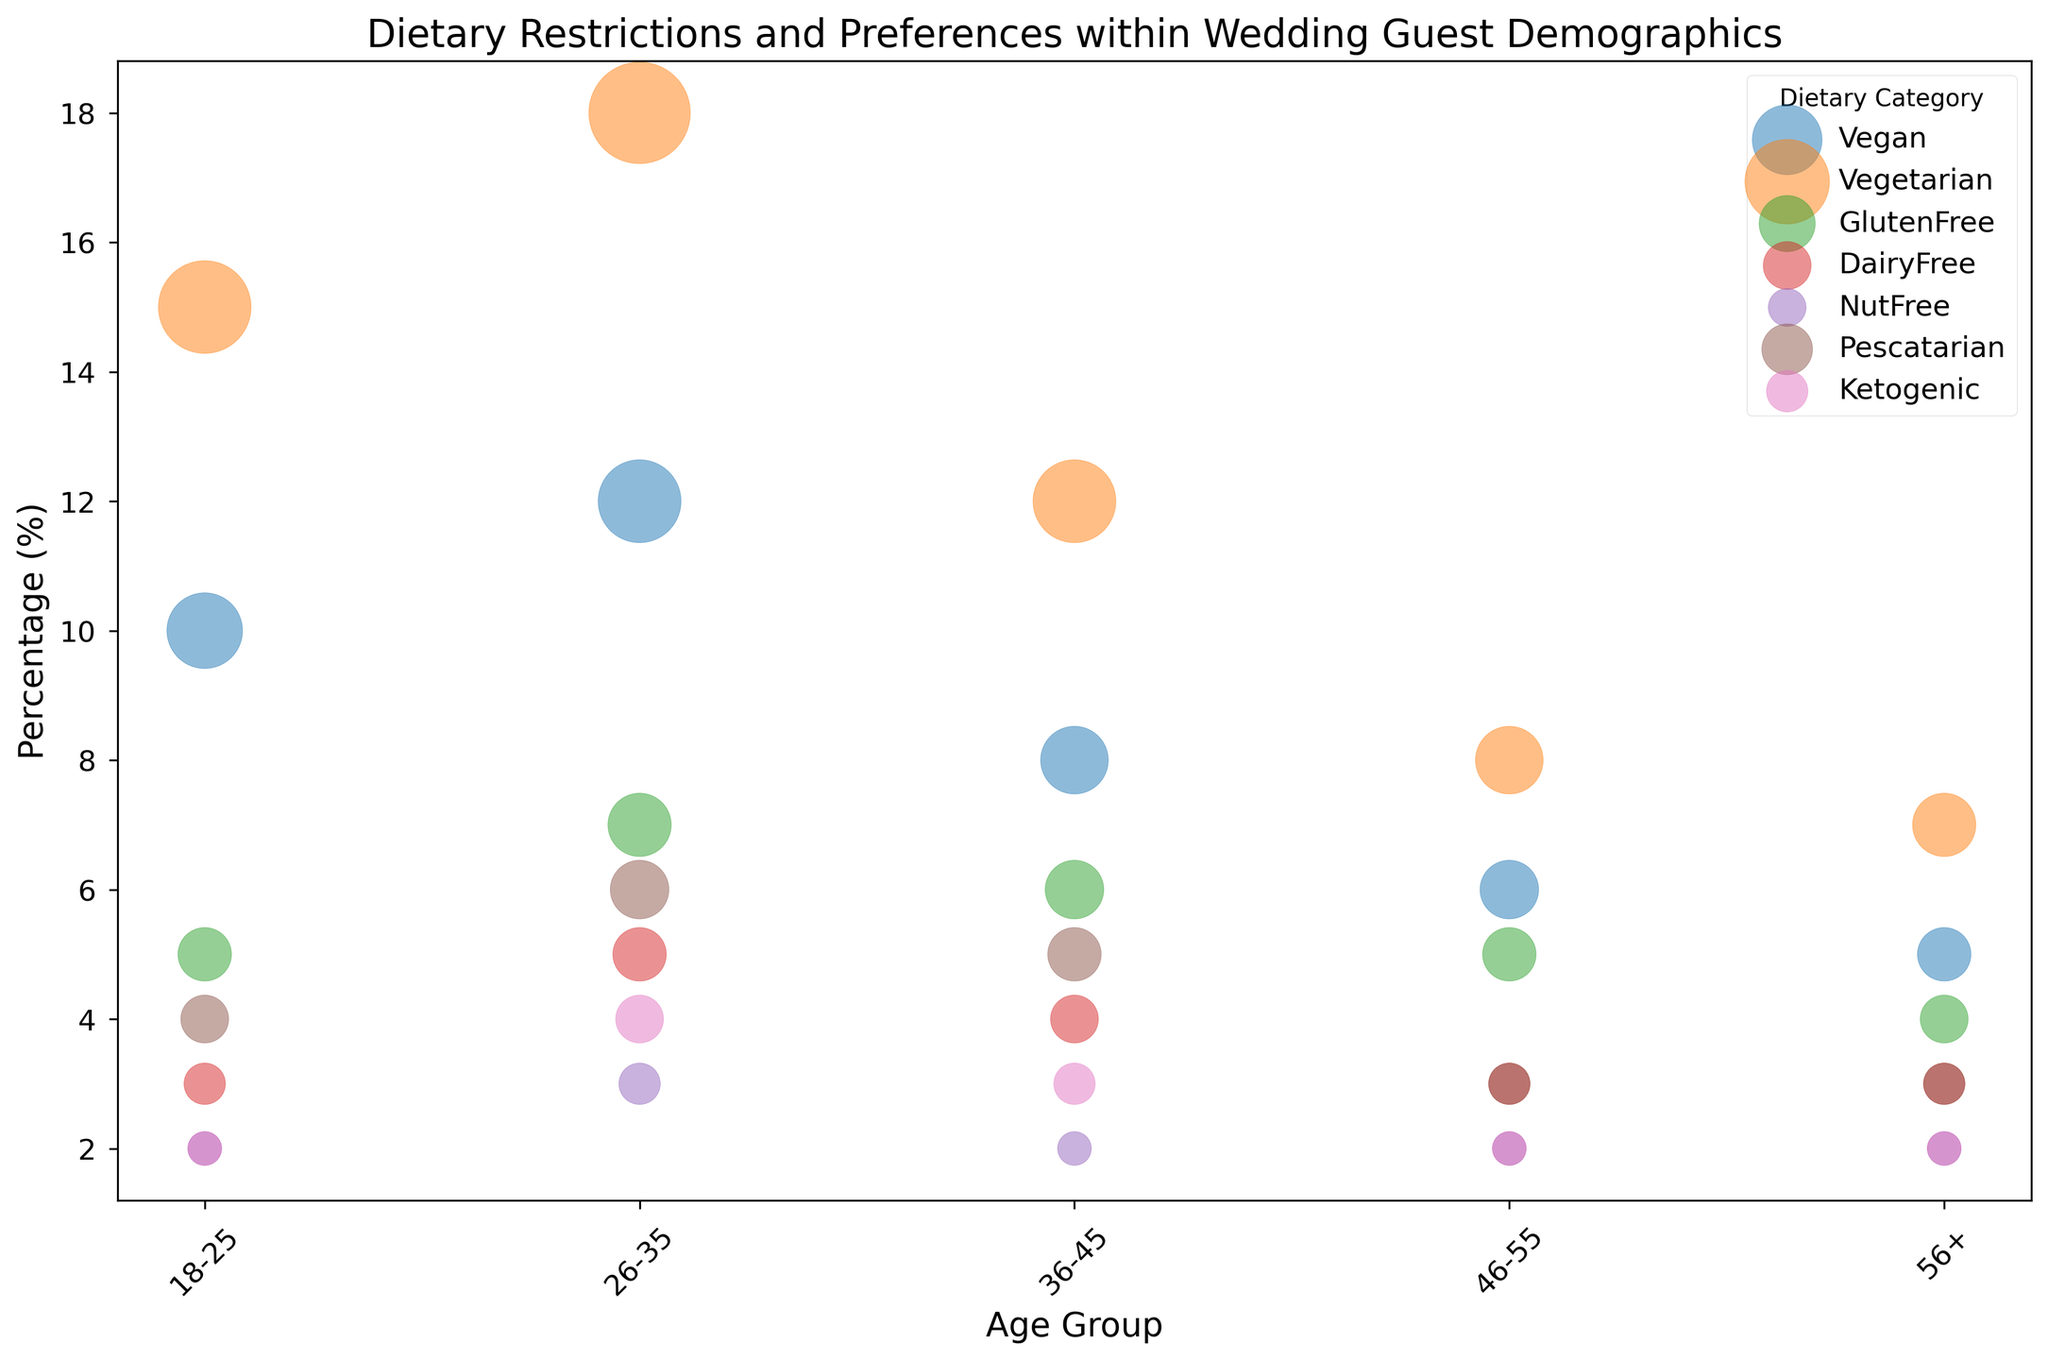What's the percentage of Vegan guests in the 26-35 age group? Locate the Vegan category in the 26-35 age group, which shows 12% on the y-axis of the bubble chart under the corresponding age group.
Answer: 12% Which dietary category has the largest number of guests in the 18-25 age group? Check the sizes of the bubbles for each category within the 18-25 age group to find the largest. The largest bubble represents the Vegetarian category with 75 guests.
Answer: Vegetarian Which age group has the highest percentage of GlutenFree guests? Compare the y-positions of the bubbles for the GlutenFree category across all age groups. The highest bubble appears for the 26-35 age group at 7%.
Answer: 26-35 How many more Vegetarian guests are there in the 26-35 age group compared to the 46-55 age group? Subtract the number of Vegetarian guests in the 46-55 age group (40) from those in the 26-35 age group (90). So, 90 - 40 = 50.
Answer: 50 What is the total number of Vegan guests across all age groups? Sum the number of Vegan guests in each age group: 50 + 60 + 40 + 30 + 25 = 205.
Answer: 205 Which dietary category in the 36-45 age group has the second smallest percentage? Look for the second lowest y-positioned bubble in the 36-45 age group. The percentages are: NutFree (2%), Ketogenic (3%), DairyFree (4%), and Pescatarian (5%). The second smallest is Ketogenic (3%).
Answer: Ketogenic Are there more DairyFree guests or NutFree guests in the 18-25 age group? Compare the bubble sizes for DairyFree and NutFree in the 18-25 age group. DairyFree has 15 guests, while NutFree has 10 guests. So, there are more DairyFree guests.
Answer: DairyFree What is the percentage difference between Vegan and Pescatarian guests in the 26-35 age group? Subtract the percentage of Pescatarian guests (6%) from the percentage of Vegan guests (12%). So, 12% - 6% = 6%.
Answer: 6% Which age group has the least number of Ketogenic guests? Observe the sizes of the bubbles for Ketogenic guests across all age groups. The smallest bubbles are in the 18-25, 46-55, and 56+ age groups, each with 10 guests, so all three have the least number.
Answer: 18-25, 46-55, 56+ Which dietary category has the smallest bubble size in the 46-55 age group? Identify the dietary category with the smallest bubble size in the 46-55 age group. Both NutFree and Ketogenic categories have the smallest bubble size, each with 10 guests.
Answer: NutFree, Ketogenic 